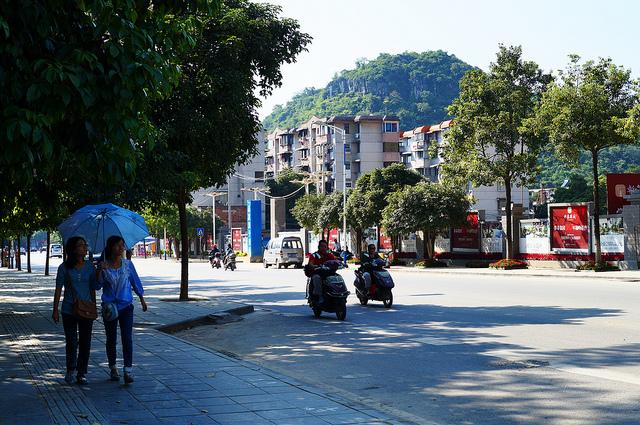Are they using this umbrella because it is raining?
Quick response, please. No. Is the woman following the man on the bike?
Answer briefly. No. How many feet are touching the ground of the man riding the motorcycle?
Write a very short answer. 0. What are the cyclist wearing on their heads?
Give a very brief answer. Helmets. How many people are under the umbrella?
Answer briefly. 2. How many motor scooters are in the scene?
Concise answer only. 2. Where is the bike?
Answer briefly. Street. 